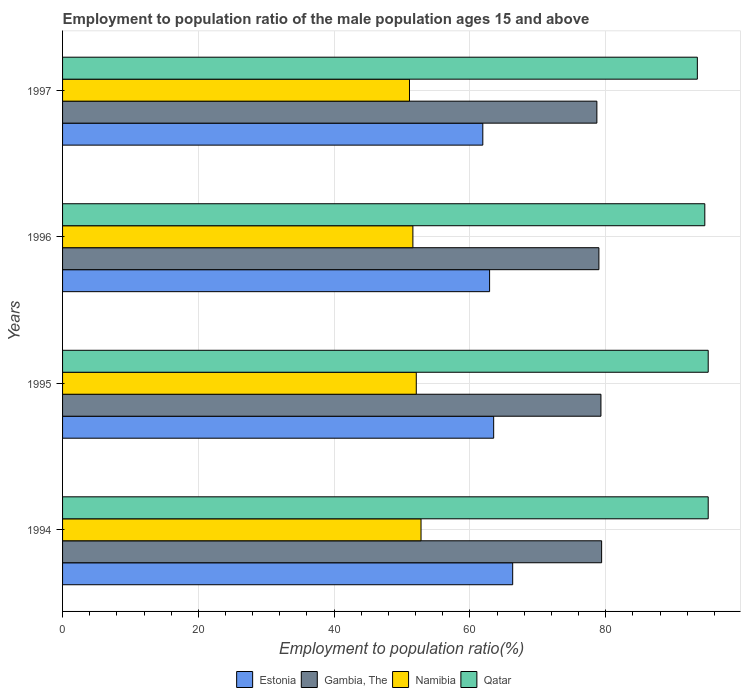Are the number of bars on each tick of the Y-axis equal?
Your response must be concise. Yes. How many bars are there on the 4th tick from the bottom?
Provide a short and direct response. 4. What is the label of the 4th group of bars from the top?
Your response must be concise. 1994. What is the employment to population ratio in Namibia in 1996?
Offer a very short reply. 51.6. Across all years, what is the maximum employment to population ratio in Namibia?
Your response must be concise. 52.8. Across all years, what is the minimum employment to population ratio in Namibia?
Keep it short and to the point. 51.1. In which year was the employment to population ratio in Namibia maximum?
Give a very brief answer. 1994. What is the total employment to population ratio in Qatar in the graph?
Make the answer very short. 378.3. What is the difference between the employment to population ratio in Estonia in 1994 and that in 1996?
Your answer should be compact. 3.4. What is the difference between the employment to population ratio in Gambia, The in 1996 and the employment to population ratio in Namibia in 1995?
Offer a terse response. 26.9. What is the average employment to population ratio in Gambia, The per year?
Keep it short and to the point. 79.1. In the year 1996, what is the difference between the employment to population ratio in Qatar and employment to population ratio in Estonia?
Make the answer very short. 31.7. In how many years, is the employment to population ratio in Gambia, The greater than 48 %?
Keep it short and to the point. 4. What is the ratio of the employment to population ratio in Estonia in 1996 to that in 1997?
Provide a short and direct response. 1.02. Is the employment to population ratio in Qatar in 1996 less than that in 1997?
Your response must be concise. No. What is the difference between the highest and the second highest employment to population ratio in Estonia?
Your response must be concise. 2.8. What is the difference between the highest and the lowest employment to population ratio in Gambia, The?
Keep it short and to the point. 0.7. Is the sum of the employment to population ratio in Gambia, The in 1995 and 1996 greater than the maximum employment to population ratio in Estonia across all years?
Make the answer very short. Yes. What does the 3rd bar from the top in 1995 represents?
Offer a very short reply. Gambia, The. What does the 4th bar from the bottom in 1994 represents?
Offer a very short reply. Qatar. Is it the case that in every year, the sum of the employment to population ratio in Qatar and employment to population ratio in Gambia, The is greater than the employment to population ratio in Estonia?
Ensure brevity in your answer.  Yes. How many bars are there?
Give a very brief answer. 16. How many years are there in the graph?
Keep it short and to the point. 4. Does the graph contain any zero values?
Offer a very short reply. No. Where does the legend appear in the graph?
Keep it short and to the point. Bottom center. What is the title of the graph?
Your answer should be very brief. Employment to population ratio of the male population ages 15 and above. Does "Trinidad and Tobago" appear as one of the legend labels in the graph?
Your answer should be compact. No. What is the label or title of the X-axis?
Provide a short and direct response. Employment to population ratio(%). What is the label or title of the Y-axis?
Your answer should be very brief. Years. What is the Employment to population ratio(%) of Estonia in 1994?
Your response must be concise. 66.3. What is the Employment to population ratio(%) in Gambia, The in 1994?
Ensure brevity in your answer.  79.4. What is the Employment to population ratio(%) in Namibia in 1994?
Your answer should be very brief. 52.8. What is the Employment to population ratio(%) in Qatar in 1994?
Provide a short and direct response. 95.1. What is the Employment to population ratio(%) of Estonia in 1995?
Provide a succinct answer. 63.5. What is the Employment to population ratio(%) in Gambia, The in 1995?
Keep it short and to the point. 79.3. What is the Employment to population ratio(%) of Namibia in 1995?
Give a very brief answer. 52.1. What is the Employment to population ratio(%) of Qatar in 1995?
Give a very brief answer. 95.1. What is the Employment to population ratio(%) of Estonia in 1996?
Your answer should be very brief. 62.9. What is the Employment to population ratio(%) in Gambia, The in 1996?
Make the answer very short. 79. What is the Employment to population ratio(%) in Namibia in 1996?
Your response must be concise. 51.6. What is the Employment to population ratio(%) of Qatar in 1996?
Provide a succinct answer. 94.6. What is the Employment to population ratio(%) of Estonia in 1997?
Provide a succinct answer. 61.9. What is the Employment to population ratio(%) of Gambia, The in 1997?
Make the answer very short. 78.7. What is the Employment to population ratio(%) of Namibia in 1997?
Keep it short and to the point. 51.1. What is the Employment to population ratio(%) in Qatar in 1997?
Give a very brief answer. 93.5. Across all years, what is the maximum Employment to population ratio(%) of Estonia?
Offer a terse response. 66.3. Across all years, what is the maximum Employment to population ratio(%) in Gambia, The?
Offer a terse response. 79.4. Across all years, what is the maximum Employment to population ratio(%) of Namibia?
Provide a short and direct response. 52.8. Across all years, what is the maximum Employment to population ratio(%) of Qatar?
Make the answer very short. 95.1. Across all years, what is the minimum Employment to population ratio(%) in Estonia?
Your answer should be very brief. 61.9. Across all years, what is the minimum Employment to population ratio(%) of Gambia, The?
Your answer should be very brief. 78.7. Across all years, what is the minimum Employment to population ratio(%) of Namibia?
Offer a very short reply. 51.1. Across all years, what is the minimum Employment to population ratio(%) of Qatar?
Make the answer very short. 93.5. What is the total Employment to population ratio(%) in Estonia in the graph?
Provide a short and direct response. 254.6. What is the total Employment to population ratio(%) of Gambia, The in the graph?
Provide a succinct answer. 316.4. What is the total Employment to population ratio(%) of Namibia in the graph?
Keep it short and to the point. 207.6. What is the total Employment to population ratio(%) in Qatar in the graph?
Provide a short and direct response. 378.3. What is the difference between the Employment to population ratio(%) of Estonia in 1994 and that in 1996?
Your answer should be compact. 3.4. What is the difference between the Employment to population ratio(%) in Gambia, The in 1994 and that in 1996?
Ensure brevity in your answer.  0.4. What is the difference between the Employment to population ratio(%) of Gambia, The in 1995 and that in 1996?
Your response must be concise. 0.3. What is the difference between the Employment to population ratio(%) of Namibia in 1995 and that in 1996?
Keep it short and to the point. 0.5. What is the difference between the Employment to population ratio(%) of Estonia in 1995 and that in 1997?
Your answer should be compact. 1.6. What is the difference between the Employment to population ratio(%) in Estonia in 1996 and that in 1997?
Make the answer very short. 1. What is the difference between the Employment to population ratio(%) of Namibia in 1996 and that in 1997?
Provide a short and direct response. 0.5. What is the difference between the Employment to population ratio(%) of Estonia in 1994 and the Employment to population ratio(%) of Gambia, The in 1995?
Ensure brevity in your answer.  -13. What is the difference between the Employment to population ratio(%) of Estonia in 1994 and the Employment to population ratio(%) of Namibia in 1995?
Your answer should be compact. 14.2. What is the difference between the Employment to population ratio(%) of Estonia in 1994 and the Employment to population ratio(%) of Qatar in 1995?
Offer a very short reply. -28.8. What is the difference between the Employment to population ratio(%) in Gambia, The in 1994 and the Employment to population ratio(%) in Namibia in 1995?
Offer a very short reply. 27.3. What is the difference between the Employment to population ratio(%) of Gambia, The in 1994 and the Employment to population ratio(%) of Qatar in 1995?
Make the answer very short. -15.7. What is the difference between the Employment to population ratio(%) of Namibia in 1994 and the Employment to population ratio(%) of Qatar in 1995?
Ensure brevity in your answer.  -42.3. What is the difference between the Employment to population ratio(%) of Estonia in 1994 and the Employment to population ratio(%) of Gambia, The in 1996?
Offer a terse response. -12.7. What is the difference between the Employment to population ratio(%) of Estonia in 1994 and the Employment to population ratio(%) of Qatar in 1996?
Provide a short and direct response. -28.3. What is the difference between the Employment to population ratio(%) of Gambia, The in 1994 and the Employment to population ratio(%) of Namibia in 1996?
Your answer should be compact. 27.8. What is the difference between the Employment to population ratio(%) in Gambia, The in 1994 and the Employment to population ratio(%) in Qatar in 1996?
Offer a very short reply. -15.2. What is the difference between the Employment to population ratio(%) of Namibia in 1994 and the Employment to population ratio(%) of Qatar in 1996?
Offer a very short reply. -41.8. What is the difference between the Employment to population ratio(%) of Estonia in 1994 and the Employment to population ratio(%) of Gambia, The in 1997?
Provide a succinct answer. -12.4. What is the difference between the Employment to population ratio(%) in Estonia in 1994 and the Employment to population ratio(%) in Qatar in 1997?
Provide a succinct answer. -27.2. What is the difference between the Employment to population ratio(%) of Gambia, The in 1994 and the Employment to population ratio(%) of Namibia in 1997?
Ensure brevity in your answer.  28.3. What is the difference between the Employment to population ratio(%) of Gambia, The in 1994 and the Employment to population ratio(%) of Qatar in 1997?
Give a very brief answer. -14.1. What is the difference between the Employment to population ratio(%) of Namibia in 1994 and the Employment to population ratio(%) of Qatar in 1997?
Offer a very short reply. -40.7. What is the difference between the Employment to population ratio(%) in Estonia in 1995 and the Employment to population ratio(%) in Gambia, The in 1996?
Keep it short and to the point. -15.5. What is the difference between the Employment to population ratio(%) in Estonia in 1995 and the Employment to population ratio(%) in Qatar in 1996?
Offer a very short reply. -31.1. What is the difference between the Employment to population ratio(%) in Gambia, The in 1995 and the Employment to population ratio(%) in Namibia in 1996?
Ensure brevity in your answer.  27.7. What is the difference between the Employment to population ratio(%) in Gambia, The in 1995 and the Employment to population ratio(%) in Qatar in 1996?
Provide a short and direct response. -15.3. What is the difference between the Employment to population ratio(%) of Namibia in 1995 and the Employment to population ratio(%) of Qatar in 1996?
Your answer should be very brief. -42.5. What is the difference between the Employment to population ratio(%) in Estonia in 1995 and the Employment to population ratio(%) in Gambia, The in 1997?
Ensure brevity in your answer.  -15.2. What is the difference between the Employment to population ratio(%) in Estonia in 1995 and the Employment to population ratio(%) in Namibia in 1997?
Your answer should be compact. 12.4. What is the difference between the Employment to population ratio(%) in Gambia, The in 1995 and the Employment to population ratio(%) in Namibia in 1997?
Make the answer very short. 28.2. What is the difference between the Employment to population ratio(%) in Namibia in 1995 and the Employment to population ratio(%) in Qatar in 1997?
Provide a short and direct response. -41.4. What is the difference between the Employment to population ratio(%) in Estonia in 1996 and the Employment to population ratio(%) in Gambia, The in 1997?
Ensure brevity in your answer.  -15.8. What is the difference between the Employment to population ratio(%) of Estonia in 1996 and the Employment to population ratio(%) of Namibia in 1997?
Offer a very short reply. 11.8. What is the difference between the Employment to population ratio(%) in Estonia in 1996 and the Employment to population ratio(%) in Qatar in 1997?
Ensure brevity in your answer.  -30.6. What is the difference between the Employment to population ratio(%) in Gambia, The in 1996 and the Employment to population ratio(%) in Namibia in 1997?
Make the answer very short. 27.9. What is the difference between the Employment to population ratio(%) in Gambia, The in 1996 and the Employment to population ratio(%) in Qatar in 1997?
Give a very brief answer. -14.5. What is the difference between the Employment to population ratio(%) in Namibia in 1996 and the Employment to population ratio(%) in Qatar in 1997?
Offer a very short reply. -41.9. What is the average Employment to population ratio(%) in Estonia per year?
Your answer should be very brief. 63.65. What is the average Employment to population ratio(%) of Gambia, The per year?
Keep it short and to the point. 79.1. What is the average Employment to population ratio(%) in Namibia per year?
Provide a short and direct response. 51.9. What is the average Employment to population ratio(%) of Qatar per year?
Make the answer very short. 94.58. In the year 1994, what is the difference between the Employment to population ratio(%) of Estonia and Employment to population ratio(%) of Qatar?
Provide a succinct answer. -28.8. In the year 1994, what is the difference between the Employment to population ratio(%) in Gambia, The and Employment to population ratio(%) in Namibia?
Give a very brief answer. 26.6. In the year 1994, what is the difference between the Employment to population ratio(%) of Gambia, The and Employment to population ratio(%) of Qatar?
Keep it short and to the point. -15.7. In the year 1994, what is the difference between the Employment to population ratio(%) in Namibia and Employment to population ratio(%) in Qatar?
Keep it short and to the point. -42.3. In the year 1995, what is the difference between the Employment to population ratio(%) of Estonia and Employment to population ratio(%) of Gambia, The?
Your answer should be very brief. -15.8. In the year 1995, what is the difference between the Employment to population ratio(%) of Estonia and Employment to population ratio(%) of Namibia?
Provide a succinct answer. 11.4. In the year 1995, what is the difference between the Employment to population ratio(%) of Estonia and Employment to population ratio(%) of Qatar?
Make the answer very short. -31.6. In the year 1995, what is the difference between the Employment to population ratio(%) in Gambia, The and Employment to population ratio(%) in Namibia?
Offer a very short reply. 27.2. In the year 1995, what is the difference between the Employment to population ratio(%) of Gambia, The and Employment to population ratio(%) of Qatar?
Keep it short and to the point. -15.8. In the year 1995, what is the difference between the Employment to population ratio(%) of Namibia and Employment to population ratio(%) of Qatar?
Provide a succinct answer. -43. In the year 1996, what is the difference between the Employment to population ratio(%) in Estonia and Employment to population ratio(%) in Gambia, The?
Offer a very short reply. -16.1. In the year 1996, what is the difference between the Employment to population ratio(%) of Estonia and Employment to population ratio(%) of Namibia?
Make the answer very short. 11.3. In the year 1996, what is the difference between the Employment to population ratio(%) in Estonia and Employment to population ratio(%) in Qatar?
Ensure brevity in your answer.  -31.7. In the year 1996, what is the difference between the Employment to population ratio(%) in Gambia, The and Employment to population ratio(%) in Namibia?
Make the answer very short. 27.4. In the year 1996, what is the difference between the Employment to population ratio(%) of Gambia, The and Employment to population ratio(%) of Qatar?
Provide a short and direct response. -15.6. In the year 1996, what is the difference between the Employment to population ratio(%) of Namibia and Employment to population ratio(%) of Qatar?
Offer a very short reply. -43. In the year 1997, what is the difference between the Employment to population ratio(%) of Estonia and Employment to population ratio(%) of Gambia, The?
Keep it short and to the point. -16.8. In the year 1997, what is the difference between the Employment to population ratio(%) in Estonia and Employment to population ratio(%) in Namibia?
Your answer should be compact. 10.8. In the year 1997, what is the difference between the Employment to population ratio(%) in Estonia and Employment to population ratio(%) in Qatar?
Your answer should be very brief. -31.6. In the year 1997, what is the difference between the Employment to population ratio(%) in Gambia, The and Employment to population ratio(%) in Namibia?
Your answer should be very brief. 27.6. In the year 1997, what is the difference between the Employment to population ratio(%) in Gambia, The and Employment to population ratio(%) in Qatar?
Your answer should be very brief. -14.8. In the year 1997, what is the difference between the Employment to population ratio(%) in Namibia and Employment to population ratio(%) in Qatar?
Your answer should be very brief. -42.4. What is the ratio of the Employment to population ratio(%) in Estonia in 1994 to that in 1995?
Ensure brevity in your answer.  1.04. What is the ratio of the Employment to population ratio(%) in Namibia in 1994 to that in 1995?
Provide a short and direct response. 1.01. What is the ratio of the Employment to population ratio(%) in Estonia in 1994 to that in 1996?
Your response must be concise. 1.05. What is the ratio of the Employment to population ratio(%) in Gambia, The in 1994 to that in 1996?
Your response must be concise. 1.01. What is the ratio of the Employment to population ratio(%) of Namibia in 1994 to that in 1996?
Keep it short and to the point. 1.02. What is the ratio of the Employment to population ratio(%) of Estonia in 1994 to that in 1997?
Provide a short and direct response. 1.07. What is the ratio of the Employment to population ratio(%) of Gambia, The in 1994 to that in 1997?
Provide a succinct answer. 1.01. What is the ratio of the Employment to population ratio(%) in Namibia in 1994 to that in 1997?
Provide a succinct answer. 1.03. What is the ratio of the Employment to population ratio(%) of Qatar in 1994 to that in 1997?
Provide a short and direct response. 1.02. What is the ratio of the Employment to population ratio(%) in Estonia in 1995 to that in 1996?
Make the answer very short. 1.01. What is the ratio of the Employment to population ratio(%) of Gambia, The in 1995 to that in 1996?
Offer a very short reply. 1. What is the ratio of the Employment to population ratio(%) of Namibia in 1995 to that in 1996?
Make the answer very short. 1.01. What is the ratio of the Employment to population ratio(%) of Qatar in 1995 to that in 1996?
Provide a short and direct response. 1.01. What is the ratio of the Employment to population ratio(%) of Estonia in 1995 to that in 1997?
Offer a terse response. 1.03. What is the ratio of the Employment to population ratio(%) of Gambia, The in 1995 to that in 1997?
Give a very brief answer. 1.01. What is the ratio of the Employment to population ratio(%) of Namibia in 1995 to that in 1997?
Give a very brief answer. 1.02. What is the ratio of the Employment to population ratio(%) of Qatar in 1995 to that in 1997?
Ensure brevity in your answer.  1.02. What is the ratio of the Employment to population ratio(%) of Estonia in 1996 to that in 1997?
Provide a short and direct response. 1.02. What is the ratio of the Employment to population ratio(%) in Namibia in 1996 to that in 1997?
Your answer should be compact. 1.01. What is the ratio of the Employment to population ratio(%) in Qatar in 1996 to that in 1997?
Offer a terse response. 1.01. What is the difference between the highest and the second highest Employment to population ratio(%) in Gambia, The?
Your answer should be compact. 0.1. What is the difference between the highest and the lowest Employment to population ratio(%) of Qatar?
Make the answer very short. 1.6. 